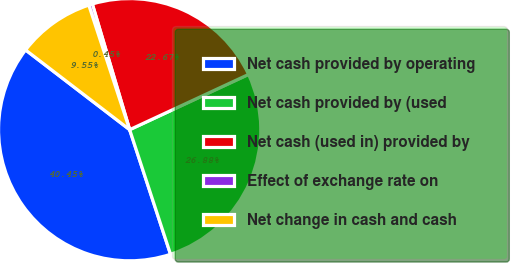<chart> <loc_0><loc_0><loc_500><loc_500><pie_chart><fcel>Net cash provided by operating<fcel>Net cash provided by (used<fcel>Net cash (used in) provided by<fcel>Effect of exchange rate on<fcel>Net change in cash and cash<nl><fcel>40.45%<fcel>26.88%<fcel>22.67%<fcel>0.45%<fcel>9.55%<nl></chart> 